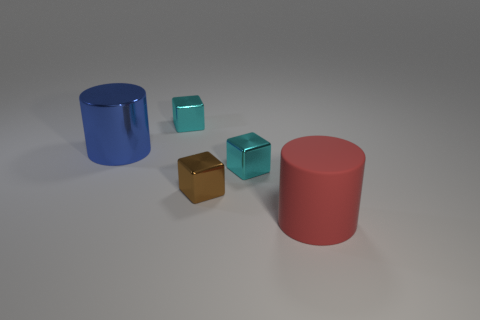Subtract all cyan blocks. How many blocks are left? 1 Add 1 tiny brown cubes. How many objects exist? 6 Subtract all brown cubes. How many cubes are left? 2 Subtract 2 cubes. How many cubes are left? 1 Subtract all cubes. How many objects are left? 2 Add 2 cylinders. How many cylinders are left? 4 Add 4 large blue metal cylinders. How many large blue metal cylinders exist? 5 Subtract 0 blue spheres. How many objects are left? 5 Subtract all gray blocks. Subtract all brown balls. How many blocks are left? 3 Subtract all yellow cylinders. How many yellow cubes are left? 0 